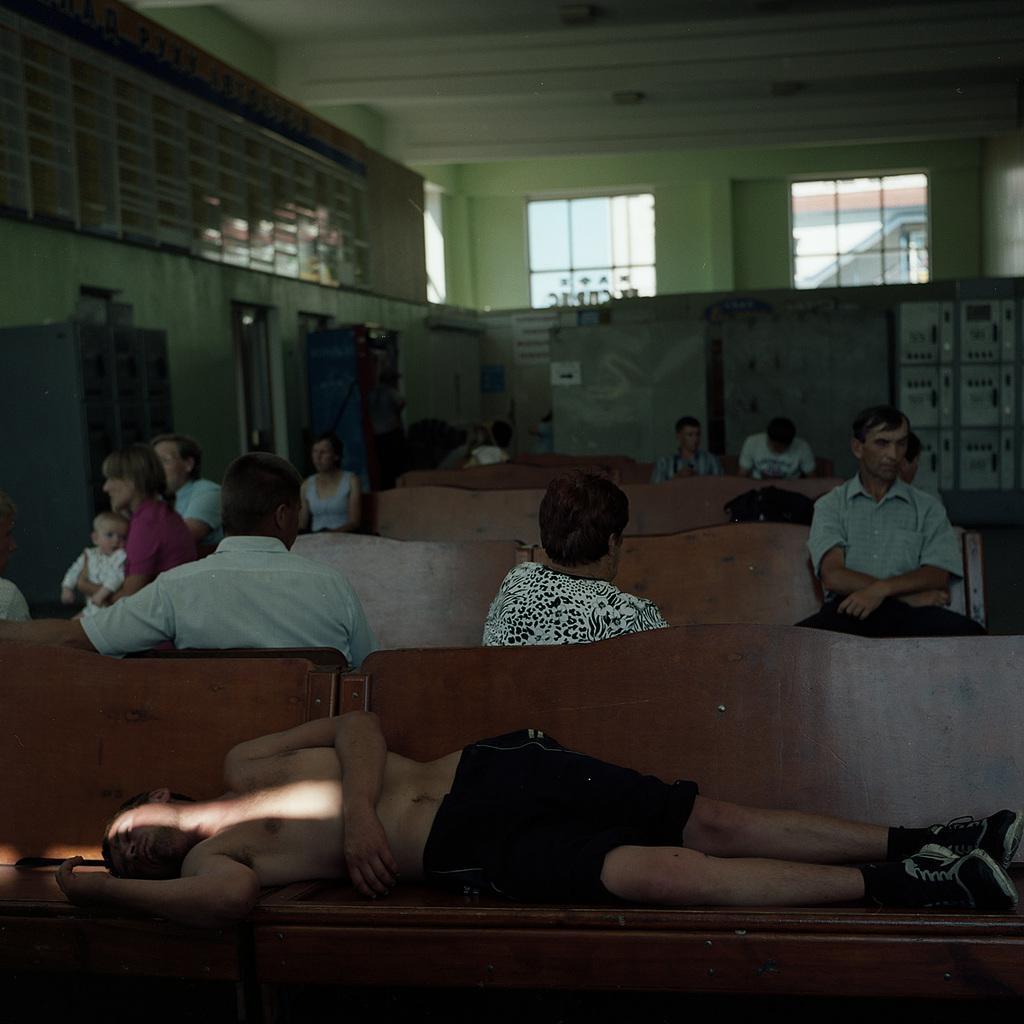Can you describe this image briefly? In this picture there is a man who is lying on the bench. Behind him I can see many peoples who are sitting on the bench. Beside them I can see the bag. In the background I can see the cotton robes, doors and windows. 